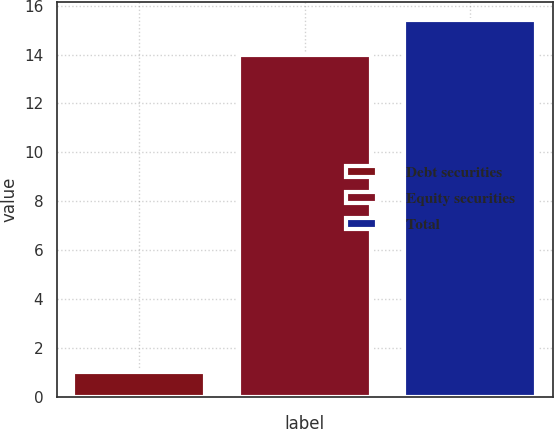<chart> <loc_0><loc_0><loc_500><loc_500><bar_chart><fcel>Debt securities<fcel>Equity securities<fcel>Total<nl><fcel>1<fcel>14<fcel>15.4<nl></chart> 